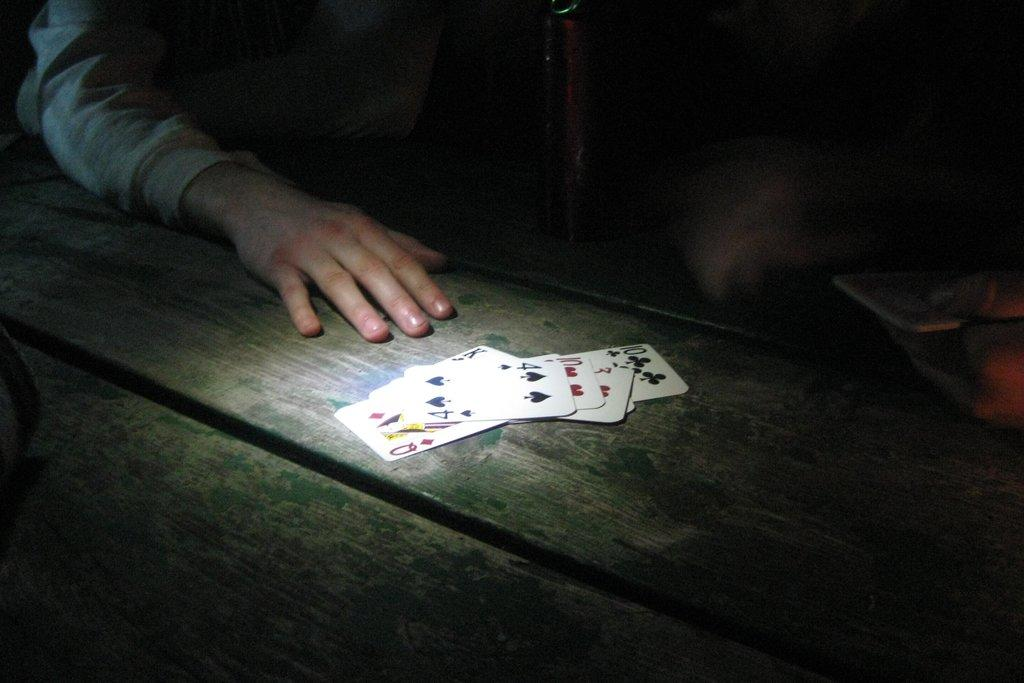What is located in the front of the image? There is a table in the front of the image. What is on the table in the image? There are playing cards on the table. Can you describe the person visible in the background of the image? Unfortunately, the provided facts do not give any information about the person in the background. What is the person's annual income in the image? There is no information about the person's income in the image. What idea does the person have for their next project in the image? There is no information about the person's ideas or projects in the image. 